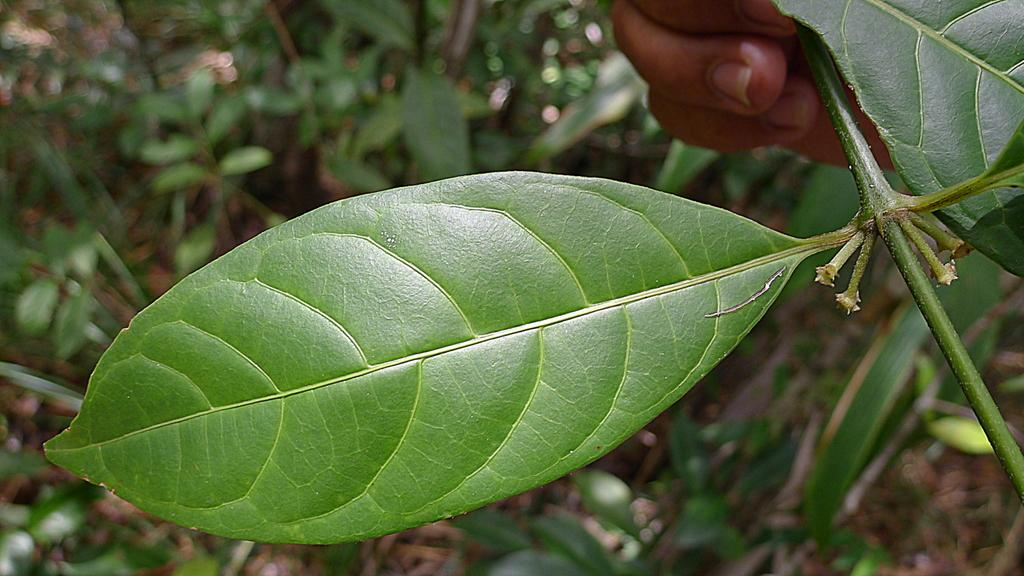What is the main object in the image? There is a leaf in the image. What is the person's hand doing in the image? A person's hand is holding a plant in the image. How would you describe the background of the image? The background of the image is blurred. What else can be seen in the background of the image? There are plants visible in the background of the image. What type of weather can be seen in the image? There is no indication of weather in the image; it only shows a leaf, a person's hand holding a plant, and a blurred background with plants. 